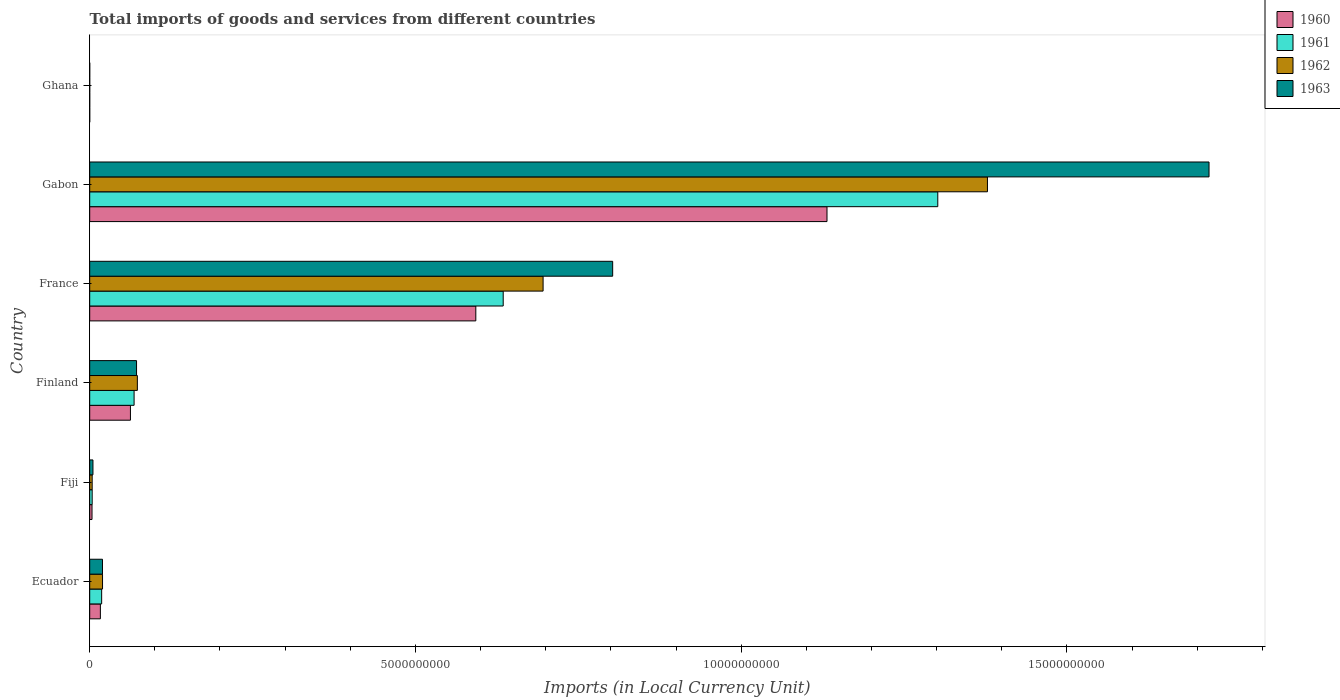How many different coloured bars are there?
Give a very brief answer. 4. How many bars are there on the 5th tick from the bottom?
Your answer should be very brief. 4. What is the label of the 2nd group of bars from the top?
Ensure brevity in your answer.  Gabon. What is the Amount of goods and services imports in 1960 in Gabon?
Keep it short and to the point. 1.13e+1. Across all countries, what is the maximum Amount of goods and services imports in 1962?
Your answer should be compact. 1.38e+1. Across all countries, what is the minimum Amount of goods and services imports in 1963?
Give a very brief answer. 3.02e+04. In which country was the Amount of goods and services imports in 1961 maximum?
Offer a terse response. Gabon. What is the total Amount of goods and services imports in 1962 in the graph?
Offer a very short reply. 2.17e+1. What is the difference between the Amount of goods and services imports in 1963 in France and that in Ghana?
Your answer should be very brief. 8.03e+09. What is the difference between the Amount of goods and services imports in 1963 in Ghana and the Amount of goods and services imports in 1960 in Finland?
Give a very brief answer. -6.25e+08. What is the average Amount of goods and services imports in 1960 per country?
Make the answer very short. 3.01e+09. What is the difference between the Amount of goods and services imports in 1961 and Amount of goods and services imports in 1963 in Ecuador?
Make the answer very short. -1.28e+07. In how many countries, is the Amount of goods and services imports in 1963 greater than 16000000000 LCU?
Your answer should be very brief. 1. What is the ratio of the Amount of goods and services imports in 1962 in Ecuador to that in Ghana?
Offer a very short reply. 7008.34. What is the difference between the highest and the second highest Amount of goods and services imports in 1961?
Your response must be concise. 6.67e+09. What is the difference between the highest and the lowest Amount of goods and services imports in 1962?
Ensure brevity in your answer.  1.38e+1. Is the sum of the Amount of goods and services imports in 1963 in Fiji and Ghana greater than the maximum Amount of goods and services imports in 1960 across all countries?
Give a very brief answer. No. What does the 4th bar from the top in Ecuador represents?
Your answer should be very brief. 1960. Is it the case that in every country, the sum of the Amount of goods and services imports in 1962 and Amount of goods and services imports in 1963 is greater than the Amount of goods and services imports in 1961?
Provide a succinct answer. Yes. How many bars are there?
Give a very brief answer. 24. How many countries are there in the graph?
Your answer should be very brief. 6. What is the difference between two consecutive major ticks on the X-axis?
Your answer should be very brief. 5.00e+09. Does the graph contain any zero values?
Your response must be concise. No. Does the graph contain grids?
Provide a short and direct response. No. Where does the legend appear in the graph?
Your answer should be very brief. Top right. How many legend labels are there?
Provide a short and direct response. 4. What is the title of the graph?
Give a very brief answer. Total imports of goods and services from different countries. What is the label or title of the X-axis?
Your response must be concise. Imports (in Local Currency Unit). What is the label or title of the Y-axis?
Offer a terse response. Country. What is the Imports (in Local Currency Unit) of 1960 in Ecuador?
Your answer should be compact. 1.64e+08. What is the Imports (in Local Currency Unit) in 1961 in Ecuador?
Offer a terse response. 1.83e+08. What is the Imports (in Local Currency Unit) of 1962 in Ecuador?
Provide a short and direct response. 1.97e+08. What is the Imports (in Local Currency Unit) of 1963 in Ecuador?
Offer a very short reply. 1.96e+08. What is the Imports (in Local Currency Unit) in 1960 in Fiji?
Your answer should be very brief. 3.56e+07. What is the Imports (in Local Currency Unit) of 1961 in Fiji?
Make the answer very short. 3.79e+07. What is the Imports (in Local Currency Unit) of 1962 in Fiji?
Ensure brevity in your answer.  3.79e+07. What is the Imports (in Local Currency Unit) of 1963 in Fiji?
Offer a very short reply. 5.00e+07. What is the Imports (in Local Currency Unit) in 1960 in Finland?
Your answer should be very brief. 6.25e+08. What is the Imports (in Local Currency Unit) of 1961 in Finland?
Provide a short and direct response. 6.81e+08. What is the Imports (in Local Currency Unit) in 1962 in Finland?
Give a very brief answer. 7.32e+08. What is the Imports (in Local Currency Unit) in 1963 in Finland?
Keep it short and to the point. 7.19e+08. What is the Imports (in Local Currency Unit) of 1960 in France?
Keep it short and to the point. 5.93e+09. What is the Imports (in Local Currency Unit) in 1961 in France?
Ensure brevity in your answer.  6.35e+09. What is the Imports (in Local Currency Unit) of 1962 in France?
Ensure brevity in your answer.  6.96e+09. What is the Imports (in Local Currency Unit) of 1963 in France?
Your response must be concise. 8.03e+09. What is the Imports (in Local Currency Unit) of 1960 in Gabon?
Provide a succinct answer. 1.13e+1. What is the Imports (in Local Currency Unit) in 1961 in Gabon?
Keep it short and to the point. 1.30e+1. What is the Imports (in Local Currency Unit) in 1962 in Gabon?
Make the answer very short. 1.38e+1. What is the Imports (in Local Currency Unit) in 1963 in Gabon?
Provide a succinct answer. 1.72e+1. What is the Imports (in Local Currency Unit) of 1960 in Ghana?
Your answer should be compact. 3.08e+04. What is the Imports (in Local Currency Unit) in 1961 in Ghana?
Offer a terse response. 3.39e+04. What is the Imports (in Local Currency Unit) of 1962 in Ghana?
Your response must be concise. 2.81e+04. What is the Imports (in Local Currency Unit) in 1963 in Ghana?
Give a very brief answer. 3.02e+04. Across all countries, what is the maximum Imports (in Local Currency Unit) of 1960?
Your answer should be very brief. 1.13e+1. Across all countries, what is the maximum Imports (in Local Currency Unit) of 1961?
Your answer should be very brief. 1.30e+1. Across all countries, what is the maximum Imports (in Local Currency Unit) in 1962?
Your answer should be compact. 1.38e+1. Across all countries, what is the maximum Imports (in Local Currency Unit) of 1963?
Offer a very short reply. 1.72e+1. Across all countries, what is the minimum Imports (in Local Currency Unit) of 1960?
Provide a succinct answer. 3.08e+04. Across all countries, what is the minimum Imports (in Local Currency Unit) in 1961?
Offer a very short reply. 3.39e+04. Across all countries, what is the minimum Imports (in Local Currency Unit) in 1962?
Provide a short and direct response. 2.81e+04. Across all countries, what is the minimum Imports (in Local Currency Unit) of 1963?
Give a very brief answer. 3.02e+04. What is the total Imports (in Local Currency Unit) of 1960 in the graph?
Ensure brevity in your answer.  1.81e+1. What is the total Imports (in Local Currency Unit) of 1961 in the graph?
Your response must be concise. 2.03e+1. What is the total Imports (in Local Currency Unit) in 1962 in the graph?
Give a very brief answer. 2.17e+1. What is the total Imports (in Local Currency Unit) in 1963 in the graph?
Offer a very short reply. 2.62e+1. What is the difference between the Imports (in Local Currency Unit) in 1960 in Ecuador and that in Fiji?
Make the answer very short. 1.28e+08. What is the difference between the Imports (in Local Currency Unit) of 1961 in Ecuador and that in Fiji?
Offer a very short reply. 1.46e+08. What is the difference between the Imports (in Local Currency Unit) in 1962 in Ecuador and that in Fiji?
Make the answer very short. 1.59e+08. What is the difference between the Imports (in Local Currency Unit) of 1963 in Ecuador and that in Fiji?
Provide a short and direct response. 1.46e+08. What is the difference between the Imports (in Local Currency Unit) in 1960 in Ecuador and that in Finland?
Your response must be concise. -4.61e+08. What is the difference between the Imports (in Local Currency Unit) in 1961 in Ecuador and that in Finland?
Ensure brevity in your answer.  -4.98e+08. What is the difference between the Imports (in Local Currency Unit) in 1962 in Ecuador and that in Finland?
Keep it short and to the point. -5.35e+08. What is the difference between the Imports (in Local Currency Unit) of 1963 in Ecuador and that in Finland?
Your response must be concise. -5.23e+08. What is the difference between the Imports (in Local Currency Unit) in 1960 in Ecuador and that in France?
Offer a very short reply. -5.76e+09. What is the difference between the Imports (in Local Currency Unit) of 1961 in Ecuador and that in France?
Give a very brief answer. -6.16e+09. What is the difference between the Imports (in Local Currency Unit) in 1962 in Ecuador and that in France?
Ensure brevity in your answer.  -6.76e+09. What is the difference between the Imports (in Local Currency Unit) in 1963 in Ecuador and that in France?
Your answer should be compact. -7.83e+09. What is the difference between the Imports (in Local Currency Unit) of 1960 in Ecuador and that in Gabon?
Your answer should be compact. -1.12e+1. What is the difference between the Imports (in Local Currency Unit) of 1961 in Ecuador and that in Gabon?
Your answer should be compact. -1.28e+1. What is the difference between the Imports (in Local Currency Unit) in 1962 in Ecuador and that in Gabon?
Make the answer very short. -1.36e+1. What is the difference between the Imports (in Local Currency Unit) in 1963 in Ecuador and that in Gabon?
Keep it short and to the point. -1.70e+1. What is the difference between the Imports (in Local Currency Unit) in 1960 in Ecuador and that in Ghana?
Ensure brevity in your answer.  1.64e+08. What is the difference between the Imports (in Local Currency Unit) in 1961 in Ecuador and that in Ghana?
Ensure brevity in your answer.  1.83e+08. What is the difference between the Imports (in Local Currency Unit) in 1962 in Ecuador and that in Ghana?
Keep it short and to the point. 1.97e+08. What is the difference between the Imports (in Local Currency Unit) in 1963 in Ecuador and that in Ghana?
Ensure brevity in your answer.  1.96e+08. What is the difference between the Imports (in Local Currency Unit) in 1960 in Fiji and that in Finland?
Keep it short and to the point. -5.90e+08. What is the difference between the Imports (in Local Currency Unit) in 1961 in Fiji and that in Finland?
Provide a succinct answer. -6.44e+08. What is the difference between the Imports (in Local Currency Unit) of 1962 in Fiji and that in Finland?
Offer a terse response. -6.94e+08. What is the difference between the Imports (in Local Currency Unit) in 1963 in Fiji and that in Finland?
Make the answer very short. -6.69e+08. What is the difference between the Imports (in Local Currency Unit) in 1960 in Fiji and that in France?
Provide a short and direct response. -5.89e+09. What is the difference between the Imports (in Local Currency Unit) of 1961 in Fiji and that in France?
Your answer should be very brief. -6.31e+09. What is the difference between the Imports (in Local Currency Unit) in 1962 in Fiji and that in France?
Provide a succinct answer. -6.92e+09. What is the difference between the Imports (in Local Currency Unit) of 1963 in Fiji and that in France?
Offer a terse response. -7.98e+09. What is the difference between the Imports (in Local Currency Unit) in 1960 in Fiji and that in Gabon?
Keep it short and to the point. -1.13e+1. What is the difference between the Imports (in Local Currency Unit) of 1961 in Fiji and that in Gabon?
Offer a very short reply. -1.30e+1. What is the difference between the Imports (in Local Currency Unit) of 1962 in Fiji and that in Gabon?
Your answer should be compact. -1.37e+1. What is the difference between the Imports (in Local Currency Unit) in 1963 in Fiji and that in Gabon?
Your answer should be compact. -1.71e+1. What is the difference between the Imports (in Local Currency Unit) in 1960 in Fiji and that in Ghana?
Your answer should be very brief. 3.56e+07. What is the difference between the Imports (in Local Currency Unit) of 1961 in Fiji and that in Ghana?
Keep it short and to the point. 3.79e+07. What is the difference between the Imports (in Local Currency Unit) in 1962 in Fiji and that in Ghana?
Offer a very short reply. 3.79e+07. What is the difference between the Imports (in Local Currency Unit) in 1963 in Fiji and that in Ghana?
Provide a short and direct response. 5.00e+07. What is the difference between the Imports (in Local Currency Unit) in 1960 in Finland and that in France?
Give a very brief answer. -5.30e+09. What is the difference between the Imports (in Local Currency Unit) in 1961 in Finland and that in France?
Your answer should be compact. -5.67e+09. What is the difference between the Imports (in Local Currency Unit) in 1962 in Finland and that in France?
Keep it short and to the point. -6.23e+09. What is the difference between the Imports (in Local Currency Unit) of 1963 in Finland and that in France?
Provide a succinct answer. -7.31e+09. What is the difference between the Imports (in Local Currency Unit) of 1960 in Finland and that in Gabon?
Keep it short and to the point. -1.07e+1. What is the difference between the Imports (in Local Currency Unit) in 1961 in Finland and that in Gabon?
Offer a very short reply. -1.23e+1. What is the difference between the Imports (in Local Currency Unit) of 1962 in Finland and that in Gabon?
Give a very brief answer. -1.30e+1. What is the difference between the Imports (in Local Currency Unit) of 1963 in Finland and that in Gabon?
Your response must be concise. -1.65e+1. What is the difference between the Imports (in Local Currency Unit) in 1960 in Finland and that in Ghana?
Offer a very short reply. 6.25e+08. What is the difference between the Imports (in Local Currency Unit) in 1961 in Finland and that in Ghana?
Ensure brevity in your answer.  6.81e+08. What is the difference between the Imports (in Local Currency Unit) in 1962 in Finland and that in Ghana?
Keep it short and to the point. 7.32e+08. What is the difference between the Imports (in Local Currency Unit) in 1963 in Finland and that in Ghana?
Make the answer very short. 7.19e+08. What is the difference between the Imports (in Local Currency Unit) in 1960 in France and that in Gabon?
Offer a very short reply. -5.39e+09. What is the difference between the Imports (in Local Currency Unit) of 1961 in France and that in Gabon?
Your answer should be very brief. -6.67e+09. What is the difference between the Imports (in Local Currency Unit) of 1962 in France and that in Gabon?
Offer a very short reply. -6.82e+09. What is the difference between the Imports (in Local Currency Unit) in 1963 in France and that in Gabon?
Offer a very short reply. -9.15e+09. What is the difference between the Imports (in Local Currency Unit) of 1960 in France and that in Ghana?
Provide a succinct answer. 5.93e+09. What is the difference between the Imports (in Local Currency Unit) in 1961 in France and that in Ghana?
Offer a terse response. 6.35e+09. What is the difference between the Imports (in Local Currency Unit) in 1962 in France and that in Ghana?
Give a very brief answer. 6.96e+09. What is the difference between the Imports (in Local Currency Unit) of 1963 in France and that in Ghana?
Keep it short and to the point. 8.03e+09. What is the difference between the Imports (in Local Currency Unit) in 1960 in Gabon and that in Ghana?
Provide a succinct answer. 1.13e+1. What is the difference between the Imports (in Local Currency Unit) in 1961 in Gabon and that in Ghana?
Offer a terse response. 1.30e+1. What is the difference between the Imports (in Local Currency Unit) of 1962 in Gabon and that in Ghana?
Make the answer very short. 1.38e+1. What is the difference between the Imports (in Local Currency Unit) in 1963 in Gabon and that in Ghana?
Your answer should be very brief. 1.72e+1. What is the difference between the Imports (in Local Currency Unit) of 1960 in Ecuador and the Imports (in Local Currency Unit) of 1961 in Fiji?
Make the answer very short. 1.26e+08. What is the difference between the Imports (in Local Currency Unit) of 1960 in Ecuador and the Imports (in Local Currency Unit) of 1962 in Fiji?
Provide a short and direct response. 1.26e+08. What is the difference between the Imports (in Local Currency Unit) in 1960 in Ecuador and the Imports (in Local Currency Unit) in 1963 in Fiji?
Provide a short and direct response. 1.14e+08. What is the difference between the Imports (in Local Currency Unit) of 1961 in Ecuador and the Imports (in Local Currency Unit) of 1962 in Fiji?
Keep it short and to the point. 1.46e+08. What is the difference between the Imports (in Local Currency Unit) of 1961 in Ecuador and the Imports (in Local Currency Unit) of 1963 in Fiji?
Ensure brevity in your answer.  1.33e+08. What is the difference between the Imports (in Local Currency Unit) in 1962 in Ecuador and the Imports (in Local Currency Unit) in 1963 in Fiji?
Provide a succinct answer. 1.47e+08. What is the difference between the Imports (in Local Currency Unit) in 1960 in Ecuador and the Imports (in Local Currency Unit) in 1961 in Finland?
Provide a short and direct response. -5.17e+08. What is the difference between the Imports (in Local Currency Unit) of 1960 in Ecuador and the Imports (in Local Currency Unit) of 1962 in Finland?
Your answer should be very brief. -5.68e+08. What is the difference between the Imports (in Local Currency Unit) in 1960 in Ecuador and the Imports (in Local Currency Unit) in 1963 in Finland?
Provide a succinct answer. -5.55e+08. What is the difference between the Imports (in Local Currency Unit) in 1961 in Ecuador and the Imports (in Local Currency Unit) in 1962 in Finland?
Give a very brief answer. -5.48e+08. What is the difference between the Imports (in Local Currency Unit) of 1961 in Ecuador and the Imports (in Local Currency Unit) of 1963 in Finland?
Offer a terse response. -5.36e+08. What is the difference between the Imports (in Local Currency Unit) in 1962 in Ecuador and the Imports (in Local Currency Unit) in 1963 in Finland?
Ensure brevity in your answer.  -5.22e+08. What is the difference between the Imports (in Local Currency Unit) of 1960 in Ecuador and the Imports (in Local Currency Unit) of 1961 in France?
Ensure brevity in your answer.  -6.18e+09. What is the difference between the Imports (in Local Currency Unit) in 1960 in Ecuador and the Imports (in Local Currency Unit) in 1962 in France?
Offer a terse response. -6.80e+09. What is the difference between the Imports (in Local Currency Unit) of 1960 in Ecuador and the Imports (in Local Currency Unit) of 1963 in France?
Your answer should be very brief. -7.86e+09. What is the difference between the Imports (in Local Currency Unit) of 1961 in Ecuador and the Imports (in Local Currency Unit) of 1962 in France?
Make the answer very short. -6.78e+09. What is the difference between the Imports (in Local Currency Unit) of 1961 in Ecuador and the Imports (in Local Currency Unit) of 1963 in France?
Your answer should be compact. -7.84e+09. What is the difference between the Imports (in Local Currency Unit) in 1962 in Ecuador and the Imports (in Local Currency Unit) in 1963 in France?
Keep it short and to the point. -7.83e+09. What is the difference between the Imports (in Local Currency Unit) of 1960 in Ecuador and the Imports (in Local Currency Unit) of 1961 in Gabon?
Ensure brevity in your answer.  -1.29e+1. What is the difference between the Imports (in Local Currency Unit) in 1960 in Ecuador and the Imports (in Local Currency Unit) in 1962 in Gabon?
Keep it short and to the point. -1.36e+1. What is the difference between the Imports (in Local Currency Unit) of 1960 in Ecuador and the Imports (in Local Currency Unit) of 1963 in Gabon?
Make the answer very short. -1.70e+1. What is the difference between the Imports (in Local Currency Unit) of 1961 in Ecuador and the Imports (in Local Currency Unit) of 1962 in Gabon?
Offer a terse response. -1.36e+1. What is the difference between the Imports (in Local Currency Unit) in 1961 in Ecuador and the Imports (in Local Currency Unit) in 1963 in Gabon?
Provide a short and direct response. -1.70e+1. What is the difference between the Imports (in Local Currency Unit) in 1962 in Ecuador and the Imports (in Local Currency Unit) in 1963 in Gabon?
Make the answer very short. -1.70e+1. What is the difference between the Imports (in Local Currency Unit) in 1960 in Ecuador and the Imports (in Local Currency Unit) in 1961 in Ghana?
Your answer should be very brief. 1.64e+08. What is the difference between the Imports (in Local Currency Unit) of 1960 in Ecuador and the Imports (in Local Currency Unit) of 1962 in Ghana?
Provide a succinct answer. 1.64e+08. What is the difference between the Imports (in Local Currency Unit) of 1960 in Ecuador and the Imports (in Local Currency Unit) of 1963 in Ghana?
Your answer should be very brief. 1.64e+08. What is the difference between the Imports (in Local Currency Unit) of 1961 in Ecuador and the Imports (in Local Currency Unit) of 1962 in Ghana?
Ensure brevity in your answer.  1.83e+08. What is the difference between the Imports (in Local Currency Unit) of 1961 in Ecuador and the Imports (in Local Currency Unit) of 1963 in Ghana?
Provide a succinct answer. 1.83e+08. What is the difference between the Imports (in Local Currency Unit) of 1962 in Ecuador and the Imports (in Local Currency Unit) of 1963 in Ghana?
Your answer should be compact. 1.97e+08. What is the difference between the Imports (in Local Currency Unit) in 1960 in Fiji and the Imports (in Local Currency Unit) in 1961 in Finland?
Offer a very short reply. -6.46e+08. What is the difference between the Imports (in Local Currency Unit) of 1960 in Fiji and the Imports (in Local Currency Unit) of 1962 in Finland?
Your answer should be compact. -6.96e+08. What is the difference between the Imports (in Local Currency Unit) in 1960 in Fiji and the Imports (in Local Currency Unit) in 1963 in Finland?
Offer a terse response. -6.84e+08. What is the difference between the Imports (in Local Currency Unit) in 1961 in Fiji and the Imports (in Local Currency Unit) in 1962 in Finland?
Your answer should be very brief. -6.94e+08. What is the difference between the Imports (in Local Currency Unit) of 1961 in Fiji and the Imports (in Local Currency Unit) of 1963 in Finland?
Make the answer very short. -6.81e+08. What is the difference between the Imports (in Local Currency Unit) in 1962 in Fiji and the Imports (in Local Currency Unit) in 1963 in Finland?
Offer a terse response. -6.81e+08. What is the difference between the Imports (in Local Currency Unit) in 1960 in Fiji and the Imports (in Local Currency Unit) in 1961 in France?
Offer a terse response. -6.31e+09. What is the difference between the Imports (in Local Currency Unit) of 1960 in Fiji and the Imports (in Local Currency Unit) of 1962 in France?
Keep it short and to the point. -6.92e+09. What is the difference between the Imports (in Local Currency Unit) in 1960 in Fiji and the Imports (in Local Currency Unit) in 1963 in France?
Your response must be concise. -7.99e+09. What is the difference between the Imports (in Local Currency Unit) of 1961 in Fiji and the Imports (in Local Currency Unit) of 1962 in France?
Offer a very short reply. -6.92e+09. What is the difference between the Imports (in Local Currency Unit) of 1961 in Fiji and the Imports (in Local Currency Unit) of 1963 in France?
Offer a very short reply. -7.99e+09. What is the difference between the Imports (in Local Currency Unit) in 1962 in Fiji and the Imports (in Local Currency Unit) in 1963 in France?
Offer a terse response. -7.99e+09. What is the difference between the Imports (in Local Currency Unit) in 1960 in Fiji and the Imports (in Local Currency Unit) in 1961 in Gabon?
Make the answer very short. -1.30e+1. What is the difference between the Imports (in Local Currency Unit) of 1960 in Fiji and the Imports (in Local Currency Unit) of 1962 in Gabon?
Keep it short and to the point. -1.37e+1. What is the difference between the Imports (in Local Currency Unit) of 1960 in Fiji and the Imports (in Local Currency Unit) of 1963 in Gabon?
Offer a terse response. -1.71e+1. What is the difference between the Imports (in Local Currency Unit) in 1961 in Fiji and the Imports (in Local Currency Unit) in 1962 in Gabon?
Give a very brief answer. -1.37e+1. What is the difference between the Imports (in Local Currency Unit) in 1961 in Fiji and the Imports (in Local Currency Unit) in 1963 in Gabon?
Offer a terse response. -1.71e+1. What is the difference between the Imports (in Local Currency Unit) in 1962 in Fiji and the Imports (in Local Currency Unit) in 1963 in Gabon?
Give a very brief answer. -1.71e+1. What is the difference between the Imports (in Local Currency Unit) of 1960 in Fiji and the Imports (in Local Currency Unit) of 1961 in Ghana?
Your response must be concise. 3.56e+07. What is the difference between the Imports (in Local Currency Unit) of 1960 in Fiji and the Imports (in Local Currency Unit) of 1962 in Ghana?
Keep it short and to the point. 3.56e+07. What is the difference between the Imports (in Local Currency Unit) of 1960 in Fiji and the Imports (in Local Currency Unit) of 1963 in Ghana?
Provide a short and direct response. 3.56e+07. What is the difference between the Imports (in Local Currency Unit) of 1961 in Fiji and the Imports (in Local Currency Unit) of 1962 in Ghana?
Your answer should be compact. 3.79e+07. What is the difference between the Imports (in Local Currency Unit) in 1961 in Fiji and the Imports (in Local Currency Unit) in 1963 in Ghana?
Provide a succinct answer. 3.79e+07. What is the difference between the Imports (in Local Currency Unit) in 1962 in Fiji and the Imports (in Local Currency Unit) in 1963 in Ghana?
Your answer should be compact. 3.79e+07. What is the difference between the Imports (in Local Currency Unit) of 1960 in Finland and the Imports (in Local Currency Unit) of 1961 in France?
Keep it short and to the point. -5.72e+09. What is the difference between the Imports (in Local Currency Unit) of 1960 in Finland and the Imports (in Local Currency Unit) of 1962 in France?
Give a very brief answer. -6.33e+09. What is the difference between the Imports (in Local Currency Unit) in 1960 in Finland and the Imports (in Local Currency Unit) in 1963 in France?
Provide a succinct answer. -7.40e+09. What is the difference between the Imports (in Local Currency Unit) of 1961 in Finland and the Imports (in Local Currency Unit) of 1962 in France?
Your response must be concise. -6.28e+09. What is the difference between the Imports (in Local Currency Unit) in 1961 in Finland and the Imports (in Local Currency Unit) in 1963 in France?
Your answer should be compact. -7.35e+09. What is the difference between the Imports (in Local Currency Unit) in 1962 in Finland and the Imports (in Local Currency Unit) in 1963 in France?
Your answer should be very brief. -7.30e+09. What is the difference between the Imports (in Local Currency Unit) in 1960 in Finland and the Imports (in Local Currency Unit) in 1961 in Gabon?
Provide a succinct answer. -1.24e+1. What is the difference between the Imports (in Local Currency Unit) of 1960 in Finland and the Imports (in Local Currency Unit) of 1962 in Gabon?
Offer a terse response. -1.32e+1. What is the difference between the Imports (in Local Currency Unit) in 1960 in Finland and the Imports (in Local Currency Unit) in 1963 in Gabon?
Your answer should be compact. -1.66e+1. What is the difference between the Imports (in Local Currency Unit) of 1961 in Finland and the Imports (in Local Currency Unit) of 1962 in Gabon?
Your response must be concise. -1.31e+1. What is the difference between the Imports (in Local Currency Unit) in 1961 in Finland and the Imports (in Local Currency Unit) in 1963 in Gabon?
Keep it short and to the point. -1.65e+1. What is the difference between the Imports (in Local Currency Unit) in 1962 in Finland and the Imports (in Local Currency Unit) in 1963 in Gabon?
Provide a succinct answer. -1.65e+1. What is the difference between the Imports (in Local Currency Unit) in 1960 in Finland and the Imports (in Local Currency Unit) in 1961 in Ghana?
Your answer should be very brief. 6.25e+08. What is the difference between the Imports (in Local Currency Unit) in 1960 in Finland and the Imports (in Local Currency Unit) in 1962 in Ghana?
Offer a terse response. 6.25e+08. What is the difference between the Imports (in Local Currency Unit) of 1960 in Finland and the Imports (in Local Currency Unit) of 1963 in Ghana?
Offer a very short reply. 6.25e+08. What is the difference between the Imports (in Local Currency Unit) in 1961 in Finland and the Imports (in Local Currency Unit) in 1962 in Ghana?
Offer a very short reply. 6.81e+08. What is the difference between the Imports (in Local Currency Unit) of 1961 in Finland and the Imports (in Local Currency Unit) of 1963 in Ghana?
Provide a succinct answer. 6.81e+08. What is the difference between the Imports (in Local Currency Unit) of 1962 in Finland and the Imports (in Local Currency Unit) of 1963 in Ghana?
Keep it short and to the point. 7.32e+08. What is the difference between the Imports (in Local Currency Unit) of 1960 in France and the Imports (in Local Currency Unit) of 1961 in Gabon?
Your answer should be compact. -7.09e+09. What is the difference between the Imports (in Local Currency Unit) of 1960 in France and the Imports (in Local Currency Unit) of 1962 in Gabon?
Provide a succinct answer. -7.85e+09. What is the difference between the Imports (in Local Currency Unit) of 1960 in France and the Imports (in Local Currency Unit) of 1963 in Gabon?
Ensure brevity in your answer.  -1.13e+1. What is the difference between the Imports (in Local Currency Unit) of 1961 in France and the Imports (in Local Currency Unit) of 1962 in Gabon?
Offer a very short reply. -7.43e+09. What is the difference between the Imports (in Local Currency Unit) in 1961 in France and the Imports (in Local Currency Unit) in 1963 in Gabon?
Your answer should be very brief. -1.08e+1. What is the difference between the Imports (in Local Currency Unit) of 1962 in France and the Imports (in Local Currency Unit) of 1963 in Gabon?
Provide a succinct answer. -1.02e+1. What is the difference between the Imports (in Local Currency Unit) of 1960 in France and the Imports (in Local Currency Unit) of 1961 in Ghana?
Ensure brevity in your answer.  5.93e+09. What is the difference between the Imports (in Local Currency Unit) in 1960 in France and the Imports (in Local Currency Unit) in 1962 in Ghana?
Your answer should be very brief. 5.93e+09. What is the difference between the Imports (in Local Currency Unit) of 1960 in France and the Imports (in Local Currency Unit) of 1963 in Ghana?
Keep it short and to the point. 5.93e+09. What is the difference between the Imports (in Local Currency Unit) in 1961 in France and the Imports (in Local Currency Unit) in 1962 in Ghana?
Ensure brevity in your answer.  6.35e+09. What is the difference between the Imports (in Local Currency Unit) in 1961 in France and the Imports (in Local Currency Unit) in 1963 in Ghana?
Offer a very short reply. 6.35e+09. What is the difference between the Imports (in Local Currency Unit) in 1962 in France and the Imports (in Local Currency Unit) in 1963 in Ghana?
Keep it short and to the point. 6.96e+09. What is the difference between the Imports (in Local Currency Unit) of 1960 in Gabon and the Imports (in Local Currency Unit) of 1961 in Ghana?
Provide a short and direct response. 1.13e+1. What is the difference between the Imports (in Local Currency Unit) of 1960 in Gabon and the Imports (in Local Currency Unit) of 1962 in Ghana?
Ensure brevity in your answer.  1.13e+1. What is the difference between the Imports (in Local Currency Unit) in 1960 in Gabon and the Imports (in Local Currency Unit) in 1963 in Ghana?
Keep it short and to the point. 1.13e+1. What is the difference between the Imports (in Local Currency Unit) of 1961 in Gabon and the Imports (in Local Currency Unit) of 1962 in Ghana?
Provide a short and direct response. 1.30e+1. What is the difference between the Imports (in Local Currency Unit) in 1961 in Gabon and the Imports (in Local Currency Unit) in 1963 in Ghana?
Make the answer very short. 1.30e+1. What is the difference between the Imports (in Local Currency Unit) of 1962 in Gabon and the Imports (in Local Currency Unit) of 1963 in Ghana?
Give a very brief answer. 1.38e+1. What is the average Imports (in Local Currency Unit) in 1960 per country?
Offer a very short reply. 3.01e+09. What is the average Imports (in Local Currency Unit) in 1961 per country?
Make the answer very short. 3.38e+09. What is the average Imports (in Local Currency Unit) of 1962 per country?
Provide a short and direct response. 3.62e+09. What is the average Imports (in Local Currency Unit) of 1963 per country?
Make the answer very short. 4.36e+09. What is the difference between the Imports (in Local Currency Unit) in 1960 and Imports (in Local Currency Unit) in 1961 in Ecuador?
Give a very brief answer. -1.95e+07. What is the difference between the Imports (in Local Currency Unit) in 1960 and Imports (in Local Currency Unit) in 1962 in Ecuador?
Keep it short and to the point. -3.29e+07. What is the difference between the Imports (in Local Currency Unit) of 1960 and Imports (in Local Currency Unit) of 1963 in Ecuador?
Offer a very short reply. -3.23e+07. What is the difference between the Imports (in Local Currency Unit) in 1961 and Imports (in Local Currency Unit) in 1962 in Ecuador?
Your response must be concise. -1.34e+07. What is the difference between the Imports (in Local Currency Unit) of 1961 and Imports (in Local Currency Unit) of 1963 in Ecuador?
Give a very brief answer. -1.28e+07. What is the difference between the Imports (in Local Currency Unit) of 1962 and Imports (in Local Currency Unit) of 1963 in Ecuador?
Make the answer very short. 6.72e+05. What is the difference between the Imports (in Local Currency Unit) in 1960 and Imports (in Local Currency Unit) in 1961 in Fiji?
Offer a very short reply. -2.30e+06. What is the difference between the Imports (in Local Currency Unit) in 1960 and Imports (in Local Currency Unit) in 1962 in Fiji?
Keep it short and to the point. -2.30e+06. What is the difference between the Imports (in Local Currency Unit) of 1960 and Imports (in Local Currency Unit) of 1963 in Fiji?
Offer a terse response. -1.44e+07. What is the difference between the Imports (in Local Currency Unit) of 1961 and Imports (in Local Currency Unit) of 1962 in Fiji?
Your response must be concise. 0. What is the difference between the Imports (in Local Currency Unit) of 1961 and Imports (in Local Currency Unit) of 1963 in Fiji?
Offer a terse response. -1.21e+07. What is the difference between the Imports (in Local Currency Unit) in 1962 and Imports (in Local Currency Unit) in 1963 in Fiji?
Your answer should be very brief. -1.21e+07. What is the difference between the Imports (in Local Currency Unit) in 1960 and Imports (in Local Currency Unit) in 1961 in Finland?
Your answer should be compact. -5.61e+07. What is the difference between the Imports (in Local Currency Unit) in 1960 and Imports (in Local Currency Unit) in 1962 in Finland?
Your answer should be very brief. -1.06e+08. What is the difference between the Imports (in Local Currency Unit) in 1960 and Imports (in Local Currency Unit) in 1963 in Finland?
Your answer should be compact. -9.39e+07. What is the difference between the Imports (in Local Currency Unit) of 1961 and Imports (in Local Currency Unit) of 1962 in Finland?
Your answer should be very brief. -5.01e+07. What is the difference between the Imports (in Local Currency Unit) in 1961 and Imports (in Local Currency Unit) in 1963 in Finland?
Offer a very short reply. -3.78e+07. What is the difference between the Imports (in Local Currency Unit) in 1962 and Imports (in Local Currency Unit) in 1963 in Finland?
Ensure brevity in your answer.  1.23e+07. What is the difference between the Imports (in Local Currency Unit) in 1960 and Imports (in Local Currency Unit) in 1961 in France?
Ensure brevity in your answer.  -4.20e+08. What is the difference between the Imports (in Local Currency Unit) of 1960 and Imports (in Local Currency Unit) of 1962 in France?
Ensure brevity in your answer.  -1.03e+09. What is the difference between the Imports (in Local Currency Unit) of 1960 and Imports (in Local Currency Unit) of 1963 in France?
Provide a succinct answer. -2.10e+09. What is the difference between the Imports (in Local Currency Unit) of 1961 and Imports (in Local Currency Unit) of 1962 in France?
Provide a short and direct response. -6.12e+08. What is the difference between the Imports (in Local Currency Unit) in 1961 and Imports (in Local Currency Unit) in 1963 in France?
Make the answer very short. -1.68e+09. What is the difference between the Imports (in Local Currency Unit) of 1962 and Imports (in Local Currency Unit) of 1963 in France?
Offer a very short reply. -1.07e+09. What is the difference between the Imports (in Local Currency Unit) in 1960 and Imports (in Local Currency Unit) in 1961 in Gabon?
Provide a succinct answer. -1.70e+09. What is the difference between the Imports (in Local Currency Unit) in 1960 and Imports (in Local Currency Unit) in 1962 in Gabon?
Ensure brevity in your answer.  -2.46e+09. What is the difference between the Imports (in Local Currency Unit) in 1960 and Imports (in Local Currency Unit) in 1963 in Gabon?
Ensure brevity in your answer.  -5.86e+09. What is the difference between the Imports (in Local Currency Unit) in 1961 and Imports (in Local Currency Unit) in 1962 in Gabon?
Give a very brief answer. -7.62e+08. What is the difference between the Imports (in Local Currency Unit) of 1961 and Imports (in Local Currency Unit) of 1963 in Gabon?
Offer a terse response. -4.16e+09. What is the difference between the Imports (in Local Currency Unit) of 1962 and Imports (in Local Currency Unit) of 1963 in Gabon?
Offer a very short reply. -3.40e+09. What is the difference between the Imports (in Local Currency Unit) of 1960 and Imports (in Local Currency Unit) of 1961 in Ghana?
Provide a short and direct response. -3100. What is the difference between the Imports (in Local Currency Unit) in 1960 and Imports (in Local Currency Unit) in 1962 in Ghana?
Keep it short and to the point. 2700. What is the difference between the Imports (in Local Currency Unit) in 1960 and Imports (in Local Currency Unit) in 1963 in Ghana?
Give a very brief answer. 600. What is the difference between the Imports (in Local Currency Unit) of 1961 and Imports (in Local Currency Unit) of 1962 in Ghana?
Your answer should be compact. 5800. What is the difference between the Imports (in Local Currency Unit) in 1961 and Imports (in Local Currency Unit) in 1963 in Ghana?
Offer a terse response. 3700. What is the difference between the Imports (in Local Currency Unit) of 1962 and Imports (in Local Currency Unit) of 1963 in Ghana?
Provide a succinct answer. -2100. What is the ratio of the Imports (in Local Currency Unit) of 1960 in Ecuador to that in Fiji?
Offer a very short reply. 4.61. What is the ratio of the Imports (in Local Currency Unit) of 1961 in Ecuador to that in Fiji?
Offer a very short reply. 4.84. What is the ratio of the Imports (in Local Currency Unit) in 1962 in Ecuador to that in Fiji?
Offer a terse response. 5.2. What is the ratio of the Imports (in Local Currency Unit) of 1963 in Ecuador to that in Fiji?
Your response must be concise. 3.93. What is the ratio of the Imports (in Local Currency Unit) of 1960 in Ecuador to that in Finland?
Keep it short and to the point. 0.26. What is the ratio of the Imports (in Local Currency Unit) in 1961 in Ecuador to that in Finland?
Offer a terse response. 0.27. What is the ratio of the Imports (in Local Currency Unit) of 1962 in Ecuador to that in Finland?
Offer a very short reply. 0.27. What is the ratio of the Imports (in Local Currency Unit) in 1963 in Ecuador to that in Finland?
Provide a succinct answer. 0.27. What is the ratio of the Imports (in Local Currency Unit) in 1960 in Ecuador to that in France?
Offer a terse response. 0.03. What is the ratio of the Imports (in Local Currency Unit) in 1961 in Ecuador to that in France?
Provide a short and direct response. 0.03. What is the ratio of the Imports (in Local Currency Unit) of 1962 in Ecuador to that in France?
Make the answer very short. 0.03. What is the ratio of the Imports (in Local Currency Unit) of 1963 in Ecuador to that in France?
Give a very brief answer. 0.02. What is the ratio of the Imports (in Local Currency Unit) in 1960 in Ecuador to that in Gabon?
Provide a short and direct response. 0.01. What is the ratio of the Imports (in Local Currency Unit) of 1961 in Ecuador to that in Gabon?
Your answer should be compact. 0.01. What is the ratio of the Imports (in Local Currency Unit) in 1962 in Ecuador to that in Gabon?
Give a very brief answer. 0.01. What is the ratio of the Imports (in Local Currency Unit) of 1963 in Ecuador to that in Gabon?
Offer a terse response. 0.01. What is the ratio of the Imports (in Local Currency Unit) of 1960 in Ecuador to that in Ghana?
Your answer should be very brief. 5324.68. What is the ratio of the Imports (in Local Currency Unit) of 1961 in Ecuador to that in Ghana?
Give a very brief answer. 5412.74. What is the ratio of the Imports (in Local Currency Unit) in 1962 in Ecuador to that in Ghana?
Your answer should be compact. 7008.34. What is the ratio of the Imports (in Local Currency Unit) of 1963 in Ecuador to that in Ghana?
Your answer should be compact. 6498.75. What is the ratio of the Imports (in Local Currency Unit) of 1960 in Fiji to that in Finland?
Offer a terse response. 0.06. What is the ratio of the Imports (in Local Currency Unit) in 1961 in Fiji to that in Finland?
Make the answer very short. 0.06. What is the ratio of the Imports (in Local Currency Unit) in 1962 in Fiji to that in Finland?
Provide a short and direct response. 0.05. What is the ratio of the Imports (in Local Currency Unit) of 1963 in Fiji to that in Finland?
Provide a succinct answer. 0.07. What is the ratio of the Imports (in Local Currency Unit) in 1960 in Fiji to that in France?
Keep it short and to the point. 0.01. What is the ratio of the Imports (in Local Currency Unit) of 1961 in Fiji to that in France?
Your answer should be very brief. 0.01. What is the ratio of the Imports (in Local Currency Unit) of 1962 in Fiji to that in France?
Ensure brevity in your answer.  0.01. What is the ratio of the Imports (in Local Currency Unit) in 1963 in Fiji to that in France?
Give a very brief answer. 0.01. What is the ratio of the Imports (in Local Currency Unit) in 1960 in Fiji to that in Gabon?
Give a very brief answer. 0. What is the ratio of the Imports (in Local Currency Unit) of 1961 in Fiji to that in Gabon?
Keep it short and to the point. 0. What is the ratio of the Imports (in Local Currency Unit) of 1962 in Fiji to that in Gabon?
Make the answer very short. 0. What is the ratio of the Imports (in Local Currency Unit) in 1963 in Fiji to that in Gabon?
Ensure brevity in your answer.  0. What is the ratio of the Imports (in Local Currency Unit) of 1960 in Fiji to that in Ghana?
Your answer should be compact. 1155.84. What is the ratio of the Imports (in Local Currency Unit) in 1961 in Fiji to that in Ghana?
Your response must be concise. 1117.99. What is the ratio of the Imports (in Local Currency Unit) in 1962 in Fiji to that in Ghana?
Keep it short and to the point. 1348.75. What is the ratio of the Imports (in Local Currency Unit) in 1963 in Fiji to that in Ghana?
Give a very brief answer. 1655.63. What is the ratio of the Imports (in Local Currency Unit) of 1960 in Finland to that in France?
Offer a terse response. 0.11. What is the ratio of the Imports (in Local Currency Unit) in 1961 in Finland to that in France?
Offer a very short reply. 0.11. What is the ratio of the Imports (in Local Currency Unit) in 1962 in Finland to that in France?
Your answer should be very brief. 0.11. What is the ratio of the Imports (in Local Currency Unit) in 1963 in Finland to that in France?
Your answer should be very brief. 0.09. What is the ratio of the Imports (in Local Currency Unit) in 1960 in Finland to that in Gabon?
Provide a short and direct response. 0.06. What is the ratio of the Imports (in Local Currency Unit) of 1961 in Finland to that in Gabon?
Your answer should be very brief. 0.05. What is the ratio of the Imports (in Local Currency Unit) of 1962 in Finland to that in Gabon?
Your answer should be compact. 0.05. What is the ratio of the Imports (in Local Currency Unit) in 1963 in Finland to that in Gabon?
Your answer should be very brief. 0.04. What is the ratio of the Imports (in Local Currency Unit) in 1960 in Finland to that in Ghana?
Your answer should be very brief. 2.03e+04. What is the ratio of the Imports (in Local Currency Unit) of 1961 in Finland to that in Ghana?
Your answer should be compact. 2.01e+04. What is the ratio of the Imports (in Local Currency Unit) in 1962 in Finland to that in Ghana?
Offer a very short reply. 2.60e+04. What is the ratio of the Imports (in Local Currency Unit) in 1963 in Finland to that in Ghana?
Keep it short and to the point. 2.38e+04. What is the ratio of the Imports (in Local Currency Unit) in 1960 in France to that in Gabon?
Offer a very short reply. 0.52. What is the ratio of the Imports (in Local Currency Unit) in 1961 in France to that in Gabon?
Provide a short and direct response. 0.49. What is the ratio of the Imports (in Local Currency Unit) in 1962 in France to that in Gabon?
Your answer should be compact. 0.51. What is the ratio of the Imports (in Local Currency Unit) in 1963 in France to that in Gabon?
Offer a very short reply. 0.47. What is the ratio of the Imports (in Local Currency Unit) in 1960 in France to that in Ghana?
Offer a terse response. 1.92e+05. What is the ratio of the Imports (in Local Currency Unit) of 1961 in France to that in Ghana?
Offer a terse response. 1.87e+05. What is the ratio of the Imports (in Local Currency Unit) of 1962 in France to that in Ghana?
Offer a very short reply. 2.48e+05. What is the ratio of the Imports (in Local Currency Unit) of 1963 in France to that in Ghana?
Give a very brief answer. 2.66e+05. What is the ratio of the Imports (in Local Currency Unit) in 1960 in Gabon to that in Ghana?
Your response must be concise. 3.67e+05. What is the ratio of the Imports (in Local Currency Unit) in 1961 in Gabon to that in Ghana?
Your response must be concise. 3.84e+05. What is the ratio of the Imports (in Local Currency Unit) of 1962 in Gabon to that in Ghana?
Your answer should be compact. 4.90e+05. What is the ratio of the Imports (in Local Currency Unit) in 1963 in Gabon to that in Ghana?
Your answer should be very brief. 5.69e+05. What is the difference between the highest and the second highest Imports (in Local Currency Unit) in 1960?
Give a very brief answer. 5.39e+09. What is the difference between the highest and the second highest Imports (in Local Currency Unit) of 1961?
Provide a short and direct response. 6.67e+09. What is the difference between the highest and the second highest Imports (in Local Currency Unit) of 1962?
Your answer should be compact. 6.82e+09. What is the difference between the highest and the second highest Imports (in Local Currency Unit) of 1963?
Keep it short and to the point. 9.15e+09. What is the difference between the highest and the lowest Imports (in Local Currency Unit) of 1960?
Offer a very short reply. 1.13e+1. What is the difference between the highest and the lowest Imports (in Local Currency Unit) in 1961?
Make the answer very short. 1.30e+1. What is the difference between the highest and the lowest Imports (in Local Currency Unit) in 1962?
Offer a very short reply. 1.38e+1. What is the difference between the highest and the lowest Imports (in Local Currency Unit) of 1963?
Give a very brief answer. 1.72e+1. 